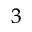Convert formula to latex. <formula><loc_0><loc_0><loc_500><loc_500>_ { 3 }</formula> 